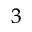Convert formula to latex. <formula><loc_0><loc_0><loc_500><loc_500>_ { 3 }</formula> 